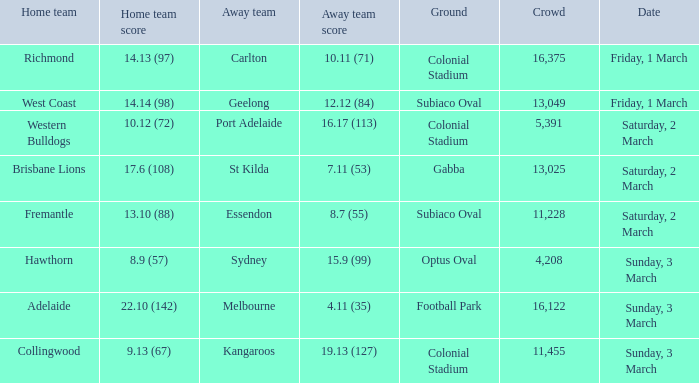What was the ground for away team essendon? Subiaco Oval. 